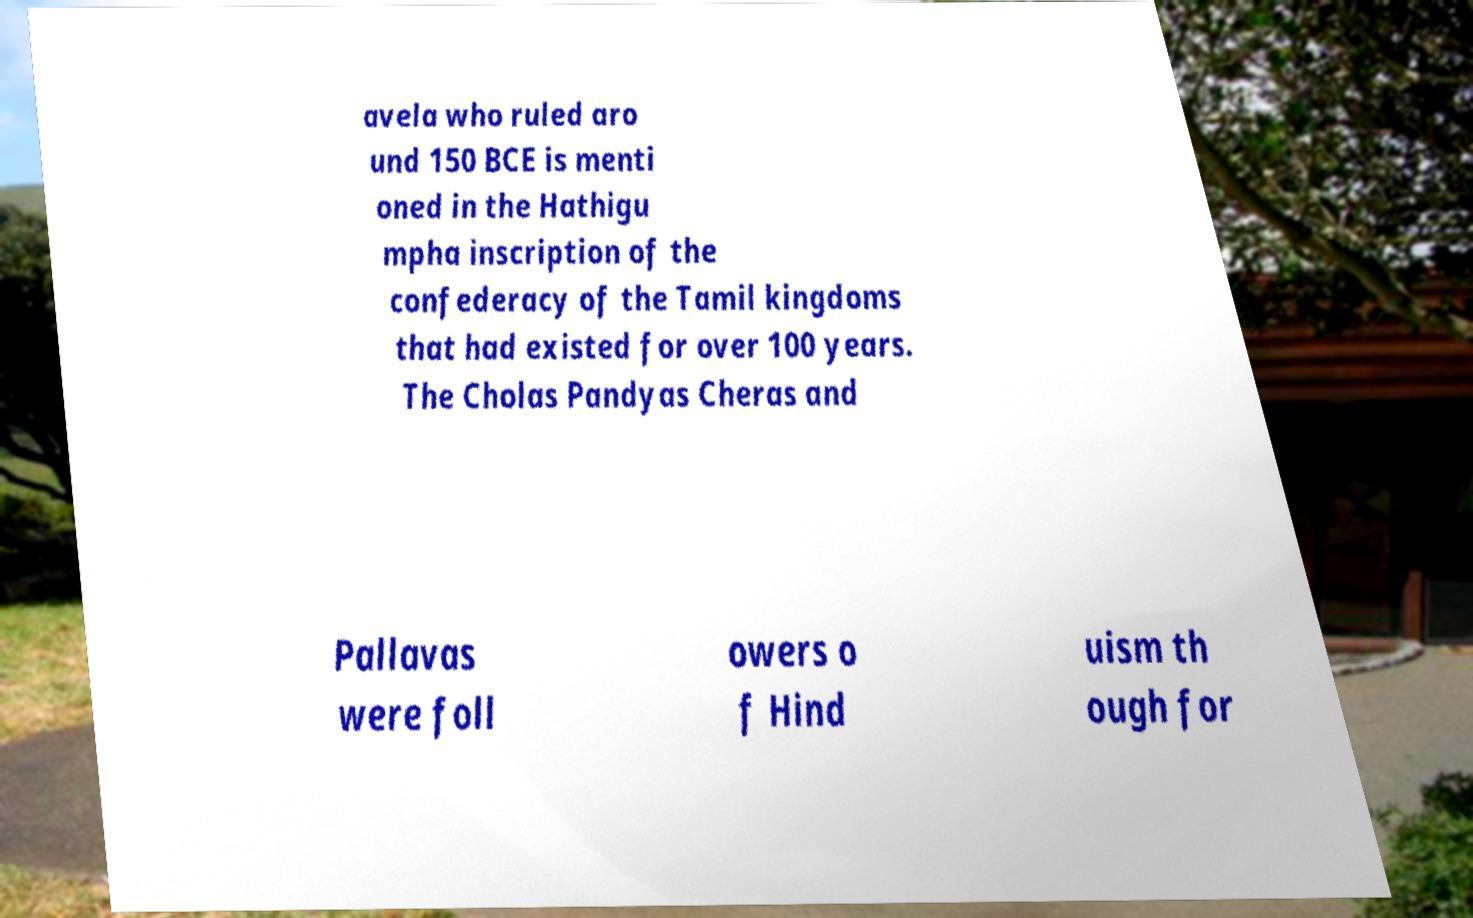Please read and relay the text visible in this image. What does it say? avela who ruled aro und 150 BCE is menti oned in the Hathigu mpha inscription of the confederacy of the Tamil kingdoms that had existed for over 100 years. The Cholas Pandyas Cheras and Pallavas were foll owers o f Hind uism th ough for 